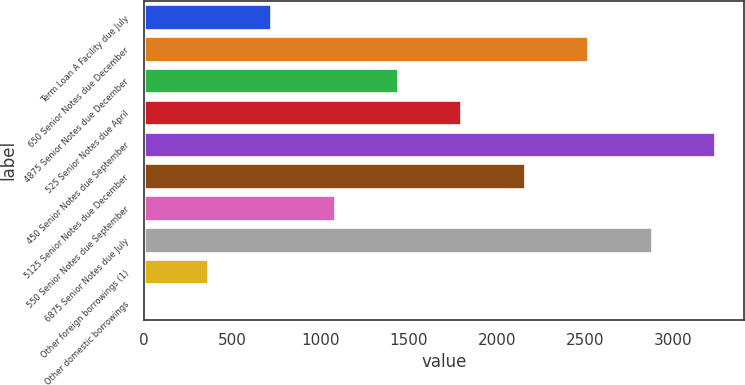<chart> <loc_0><loc_0><loc_500><loc_500><bar_chart><fcel>Term Loan A Facility due July<fcel>650 Senior Notes due December<fcel>4875 Senior Notes due December<fcel>525 Senior Notes due April<fcel>450 Senior Notes due September<fcel>5125 Senior Notes due December<fcel>550 Senior Notes due September<fcel>6875 Senior Notes due July<fcel>Other foreign borrowings (1)<fcel>Other domestic borrowings<nl><fcel>722.12<fcel>2518.42<fcel>1440.64<fcel>1799.9<fcel>3236.94<fcel>2159.16<fcel>1081.38<fcel>2877.68<fcel>362.86<fcel>3.6<nl></chart> 